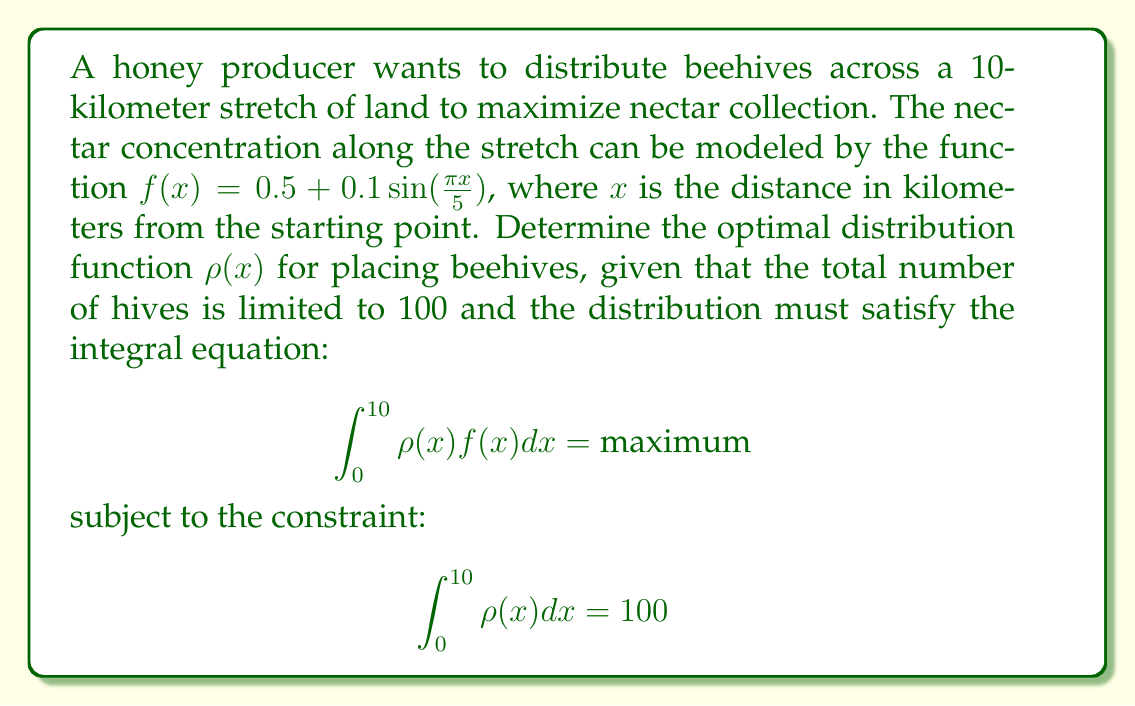What is the answer to this math problem? To solve this problem, we'll use the method of Lagrange multipliers:

1) Let's define the Lagrangian function:
   $$L(\rho, \lambda) = \int_0^{10} \rho(x)f(x)dx - \lambda(\int_0^{10} \rho(x)dx - 100)$$

2) For the optimal solution, the functional derivative of L with respect to $\rho(x)$ should be zero:
   $$\frac{\delta L}{\delta \rho} = f(x) - \lambda = 0$$

3) This implies:
   $$\rho(x) = \begin{cases} 
      \text{maximum allowed}, & \text{if } f(x) > \lambda \\
      0, & \text{if } f(x) < \lambda
   \end{cases}$$

4) Given $f(x) = 0.5 + 0.1\sin(\frac{\pi x}{5})$, we can see that $f(x)$ oscillates between 0.4 and 0.6.

5) To satisfy the constraint of 100 total hives, we need to choose $\lambda$ such that $\rho(x)$ is positive when $f(x) > \lambda$ and zero otherwise, and the total integral equals 100.

6) By trial and error or numerical methods, we find that $\lambda \approx 0.5$ satisfies this condition.

7) Therefore, the optimal distribution is:
   $$\rho(x) = \begin{cases} 
      K, & \text{if } 0.5 + 0.1\sin(\frac{\pi x}{5}) > 0.5 \\
      0, & \text{otherwise}
   \end{cases}$$

   where K is a large number (theoretically infinite, but practically limited by physical constraints).

8) This distribution places hives densely in regions where the nectar concentration is above average (>0.5) and no hives where it's below average.
Answer: $\rho(x) = \begin{cases} 
   K, & \text{if } \sin(\frac{\pi x}{5}) > 0 \\
   0, & \text{otherwise}
\end{cases}$, where K is large 